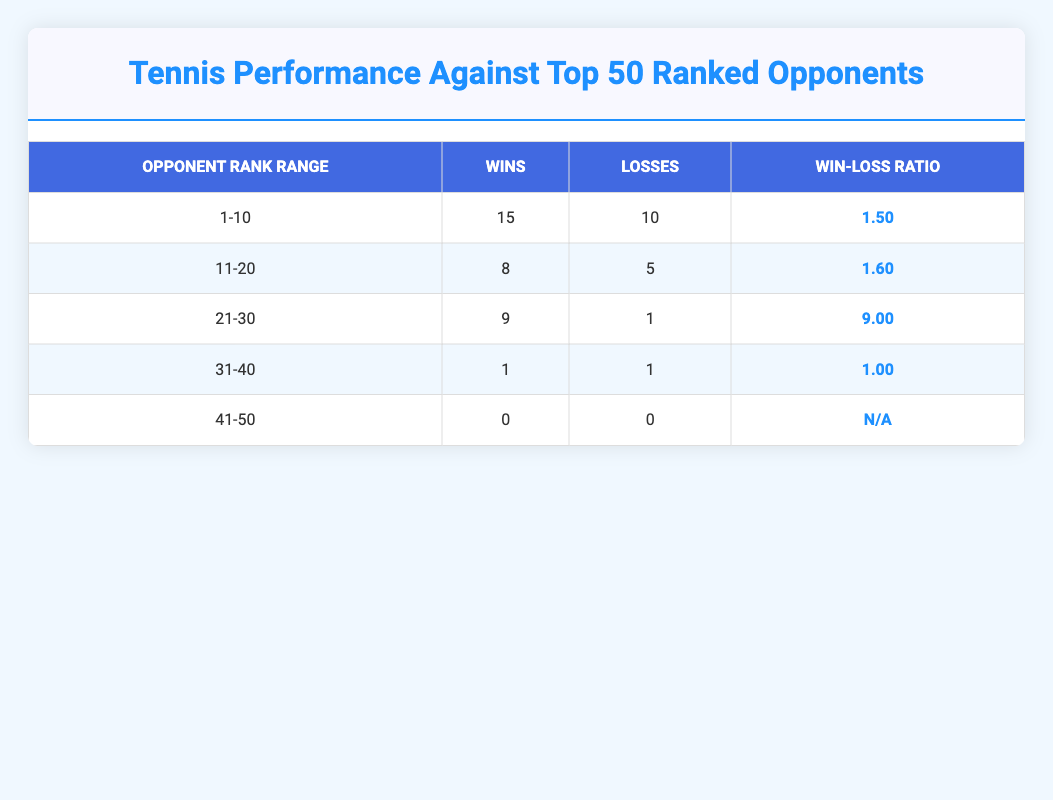What is the total number of wins against opponents ranked 1 to 10? To find the total wins against opponents ranked 1 to 10, we look at the 'Wins' column in the '1-10' row, which shows 15 wins.
Answer: 15 What is the win-loss ratio against opponents ranked 21 to 30? The win-loss ratio is calculated by dividing the total wins (9) by the total losses (1) for opponents ranked 21 to 30. Thus, 9 divided by 1 equals 9.00.
Answer: 9.00 Did the player win any matches against opponents ranked 41 to 50? In the '41-50' row, the table shows 0 wins and 0 losses, which means the player did not win any matches against this rank range.
Answer: No How many more wins does the player have against opponents ranked 11 to 20 compared to those ranked 31 to 40? The total wins against opponents ranked 11 to 20 is 8, while the total wins against those ranked 31 to 40 is 1. Therefore, the difference in wins is 8 minus 1, which equals 7.
Answer: 7 What is the overall win-loss ratio against all ranked opponents? To calculate the overall win-loss ratio, we need to sum the total wins and losses from all rank ranges. Adding all wins (15 + 8 + 9 + 1 + 0) gives 33 wins, and adding all losses (10 + 5 + 1 + 1 + 0) gives 17 losses. The ratio is then 33 divided by 17, which is about 1.94.
Answer: 1.94 Is the player undefeated against opponents ranked 21 to 30? The row for opponents ranked 21 to 30 shows 9 wins and 1 loss, indicating the player has lost against at least one opponent in this rank range.
Answer: No What is the win-loss ratio against opponents ranked 11 to 20 compared to those ranked 1 to 10? For opponents ranked 1 to 10, the win-loss ratio is 15 wins to 10 losses (1.50). For opponents ranked 11 to 20, it is 8 wins to 5 losses (1.60). Comparing both ratios shows that the player has a better ratio against opponents ranked 11 to 20.
Answer: 1.60 is better than 1.50 How do the total losses against opponents ranked 31 to 40 compare to those ranked 21 to 30? The losses against opponents ranked 31 to 40 total 1, while the losses against those ranked 21 to 30 total 1. They are equal in total losses.
Answer: Equal What is the total number of matches played against all opponents ranked 1 to 20? To find the total matches, we sum up the wins and losses for rank ranges 1 to 10 (15 wins + 10 losses = 25) and 11 to 20 (8 wins + 5 losses = 13). Therefore, the total is 25 + 13 = 38 matches played against opponents ranked 1 to 20.
Answer: 38 